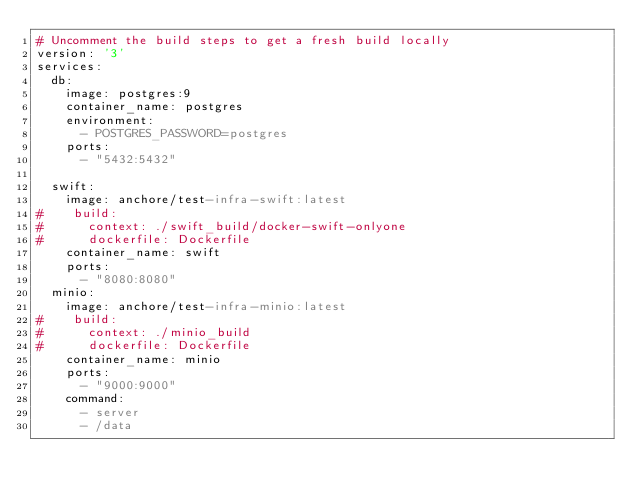Convert code to text. <code><loc_0><loc_0><loc_500><loc_500><_YAML_># Uncomment the build steps to get a fresh build locally
version: '3'
services:
  db:
    image: postgres:9
    container_name: postgres
    environment: 
      - POSTGRES_PASSWORD=postgres
    ports:
      - "5432:5432"

  swift:
    image: anchore/test-infra-swift:latest
#    build:
#      context: ./swift_build/docker-swift-onlyone
#      dockerfile: Dockerfile
    container_name: swift
    ports:
      - "8080:8080"
  minio:
    image: anchore/test-infra-minio:latest
#    build:
#      context: ./minio_build
#      dockerfile: Dockerfile
    container_name: minio
    ports:
      - "9000:9000"
    command:
      - server
      - /data

</code> 